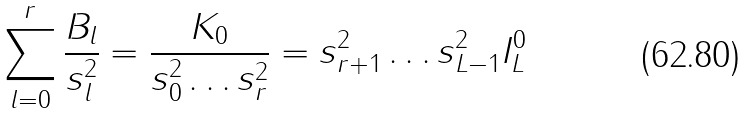Convert formula to latex. <formula><loc_0><loc_0><loc_500><loc_500>\sum _ { l = 0 } ^ { r } \frac { B _ { l } } { s _ { l } ^ { 2 } } = \frac { K _ { 0 } } { s _ { 0 } ^ { 2 } \dots s _ { r } ^ { 2 } } = s _ { r + 1 } ^ { 2 } \dots s _ { L - 1 } ^ { 2 } I _ { L } ^ { 0 }</formula> 